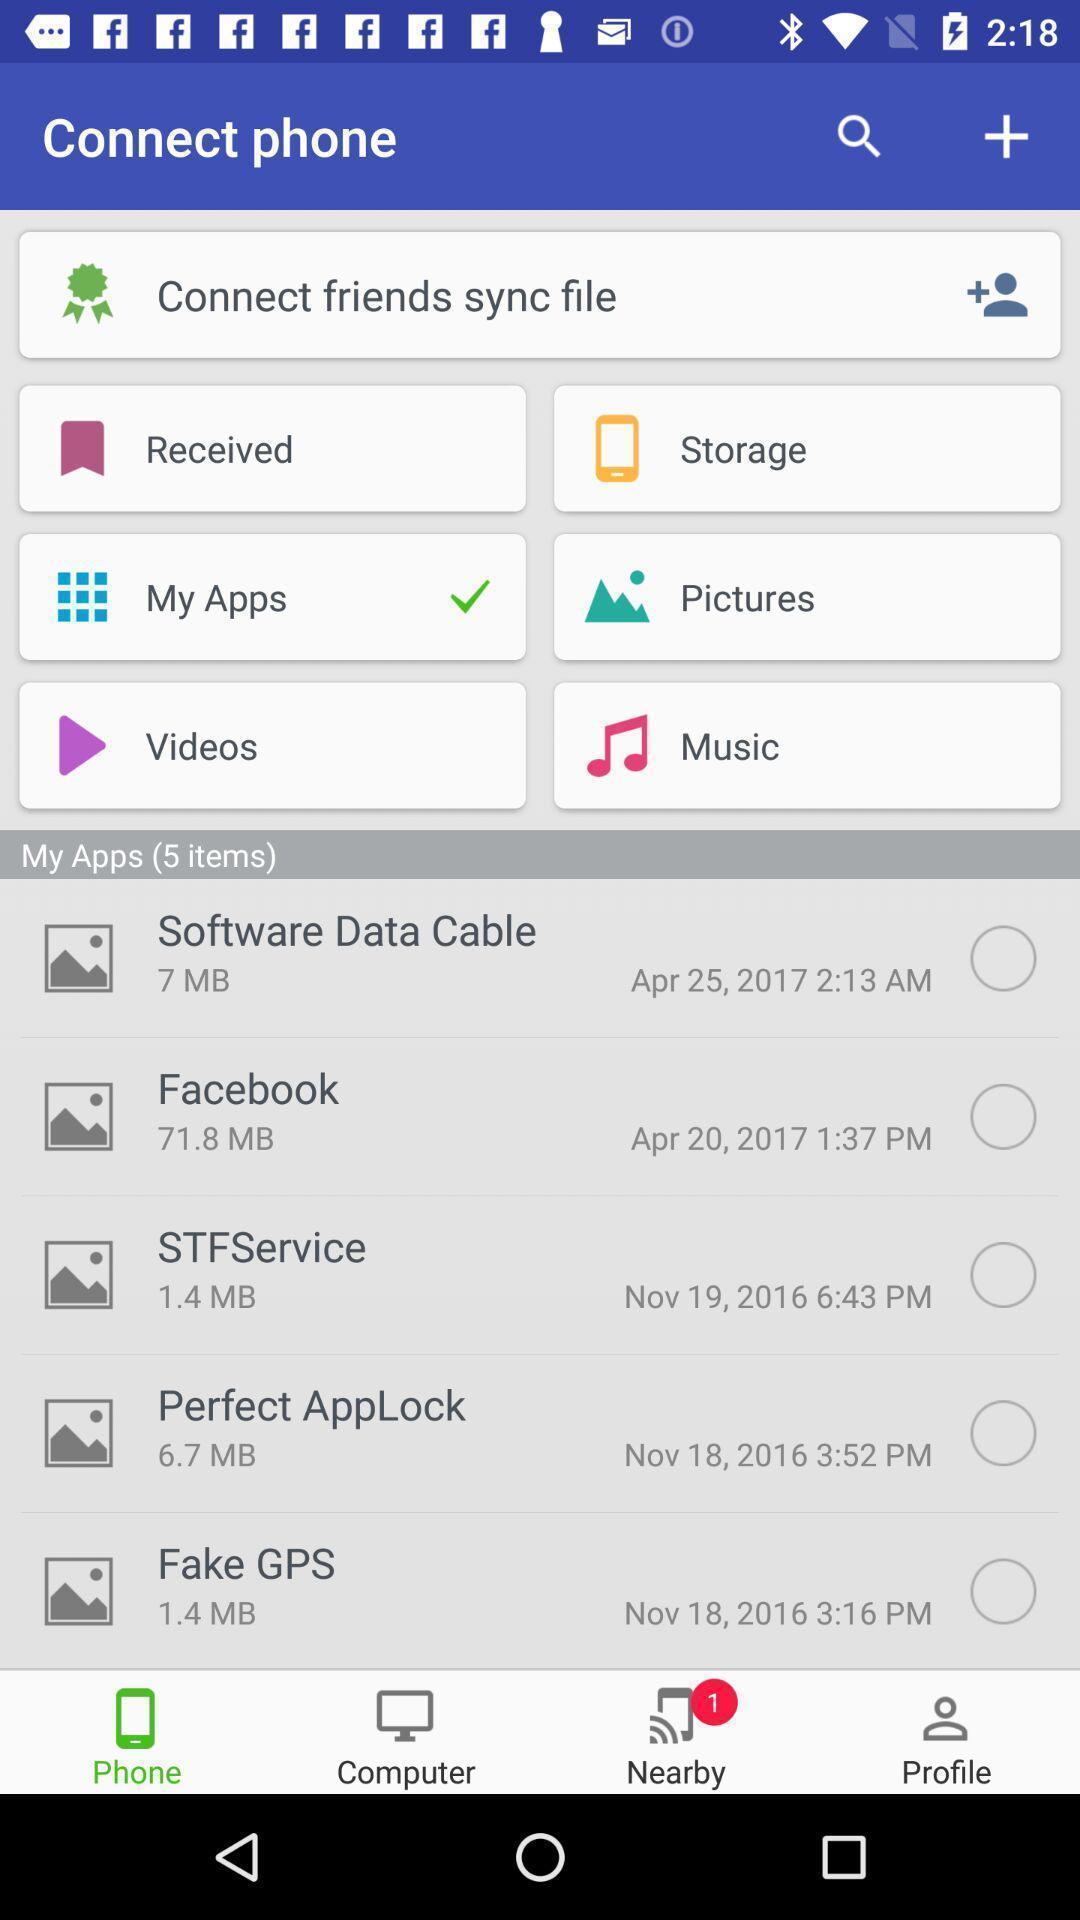Provide a description of this screenshot. Screen shows multiple options in an communication app. 